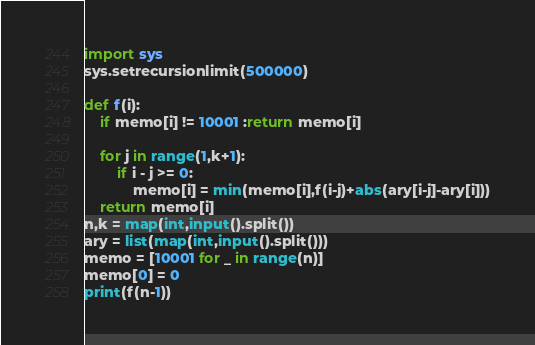<code> <loc_0><loc_0><loc_500><loc_500><_Python_>import sys
sys.setrecursionlimit(500000)

def f(i):
    if memo[i] != 10001 :return memo[i]

    for j in range(1,k+1):
        if i - j >= 0:
            memo[i] = min(memo[i],f(i-j)+abs(ary[i-j]-ary[i]))
    return memo[i]
n,k = map(int,input().split())
ary = list(map(int,input().split()))
memo = [10001 for _ in range(n)]
memo[0] = 0
print(f(n-1))</code> 